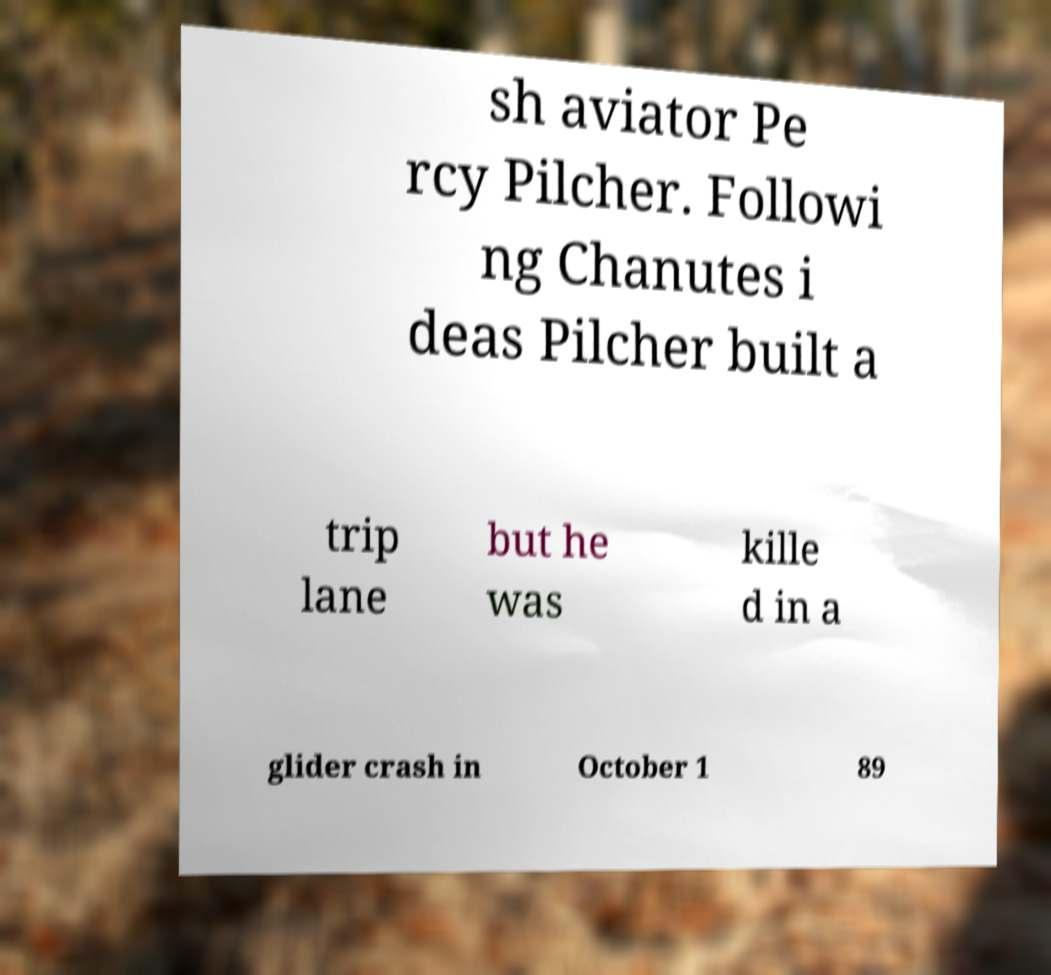There's text embedded in this image that I need extracted. Can you transcribe it verbatim? sh aviator Pe rcy Pilcher. Followi ng Chanutes i deas Pilcher built a trip lane but he was kille d in a glider crash in October 1 89 